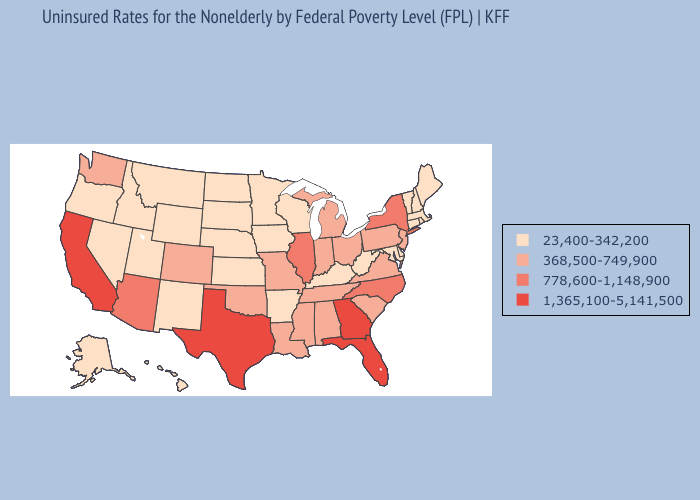Among the states that border New Mexico , does Utah have the highest value?
Give a very brief answer. No. Does Alabama have a higher value than Illinois?
Write a very short answer. No. Among the states that border Nebraska , does South Dakota have the highest value?
Short answer required. No. What is the highest value in the USA?
Short answer required. 1,365,100-5,141,500. Name the states that have a value in the range 778,600-1,148,900?
Be succinct. Arizona, Illinois, New York, North Carolina. Name the states that have a value in the range 778,600-1,148,900?
Write a very short answer. Arizona, Illinois, New York, North Carolina. Does West Virginia have the lowest value in the USA?
Give a very brief answer. Yes. How many symbols are there in the legend?
Keep it brief. 4. Does Delaware have the lowest value in the USA?
Concise answer only. Yes. What is the value of North Dakota?
Short answer required. 23,400-342,200. Among the states that border Kansas , which have the highest value?
Be succinct. Colorado, Missouri, Oklahoma. Does Kentucky have a higher value than Maryland?
Concise answer only. No. What is the highest value in the USA?
Short answer required. 1,365,100-5,141,500. Name the states that have a value in the range 778,600-1,148,900?
Answer briefly. Arizona, Illinois, New York, North Carolina. Which states hav the highest value in the West?
Answer briefly. California. 